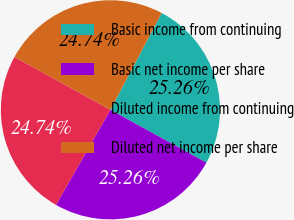Convert chart to OTSL. <chart><loc_0><loc_0><loc_500><loc_500><pie_chart><fcel>Basic income from continuing<fcel>Basic net income per share<fcel>Diluted income from continuing<fcel>Diluted net income per share<nl><fcel>25.26%<fcel>25.26%<fcel>24.74%<fcel>24.74%<nl></chart> 